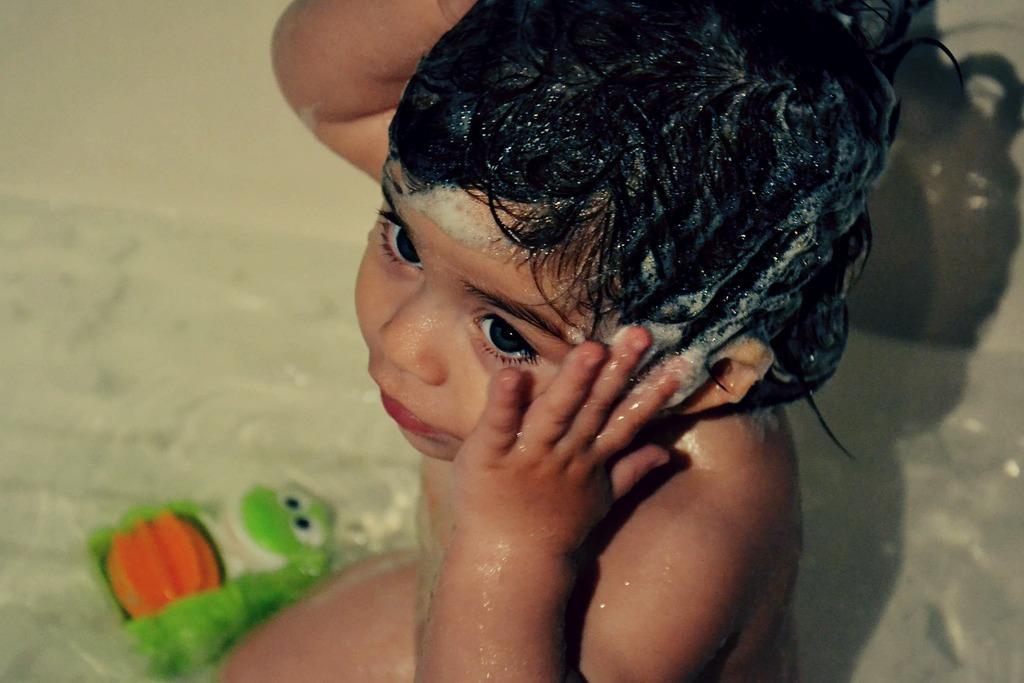Please provide a concise description of this image. There is a baby and there is a foam on the head of the baby, beside the baby there is a toy and the background is blurry. 